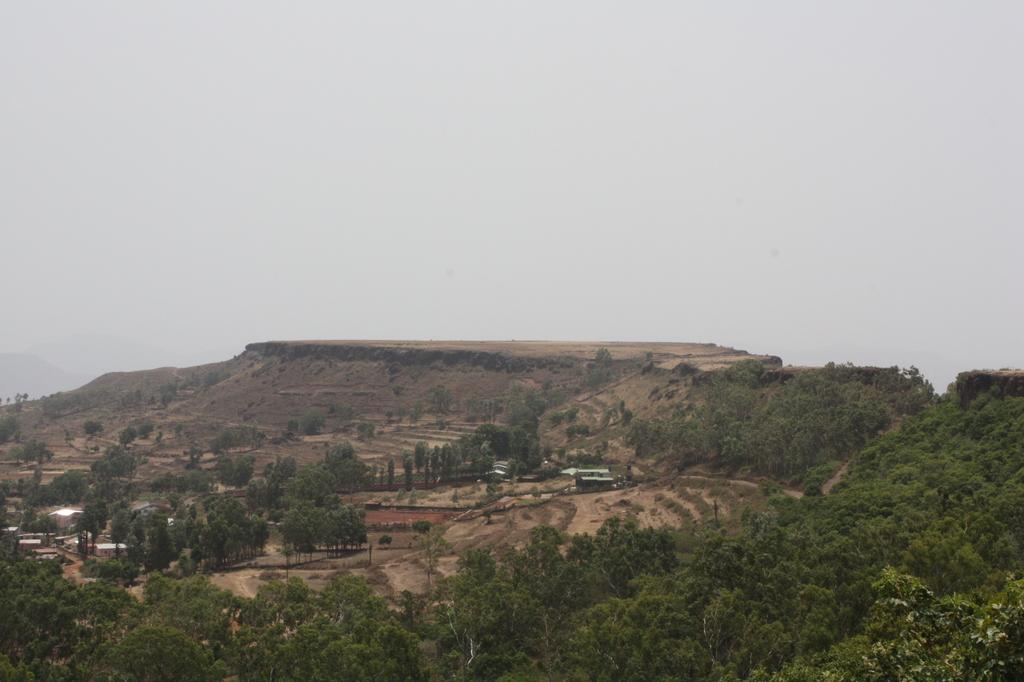What type of view is shown in the image? The image is an outside view. What can be seen at the bottom of the image? There are many trees at the bottom of the image. What is visible in the background of the image? There are houses and land visible in the background of the image. What is visible at the top of the image? The sky is visible at the top of the image. What type of silverware is used for the dinner in the image? There is no dinner or silverware present in the image; it is an outside view with trees, houses, land, and sky. Can you see a snake in the image? There is no snake present in the image. 